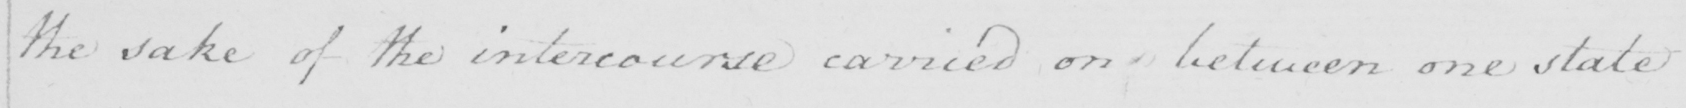Can you tell me what this handwritten text says? the sake of the intercourse carried on between one state 